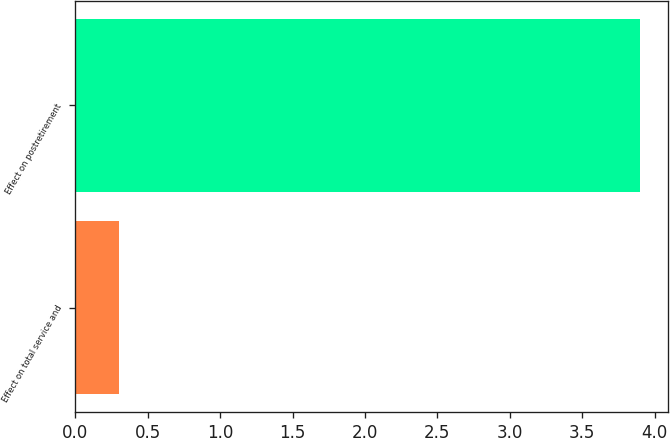Convert chart to OTSL. <chart><loc_0><loc_0><loc_500><loc_500><bar_chart><fcel>Effect on total service and<fcel>Effect on postretirement<nl><fcel>0.3<fcel>3.9<nl></chart> 